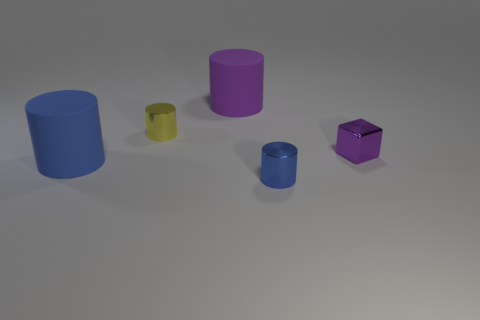Subtract 1 cylinders. How many cylinders are left? 3 Add 2 small rubber cylinders. How many objects exist? 7 Subtract all cylinders. How many objects are left? 1 Add 4 large objects. How many large objects exist? 6 Subtract 0 blue cubes. How many objects are left? 5 Subtract all blue objects. Subtract all tiny blue objects. How many objects are left? 2 Add 3 small metal cylinders. How many small metal cylinders are left? 5 